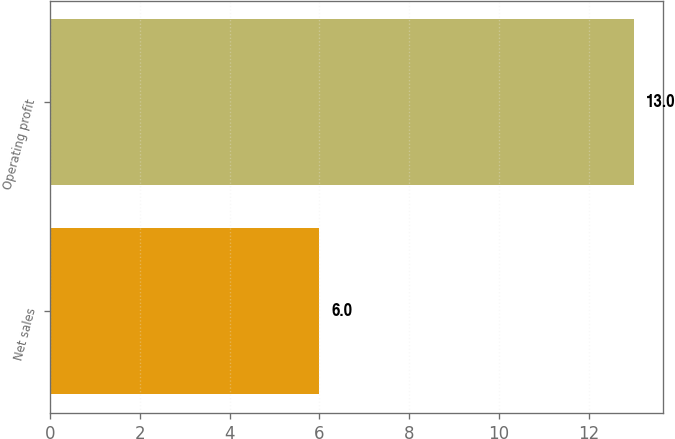Convert chart. <chart><loc_0><loc_0><loc_500><loc_500><bar_chart><fcel>Net sales<fcel>Operating profit<nl><fcel>6<fcel>13<nl></chart> 